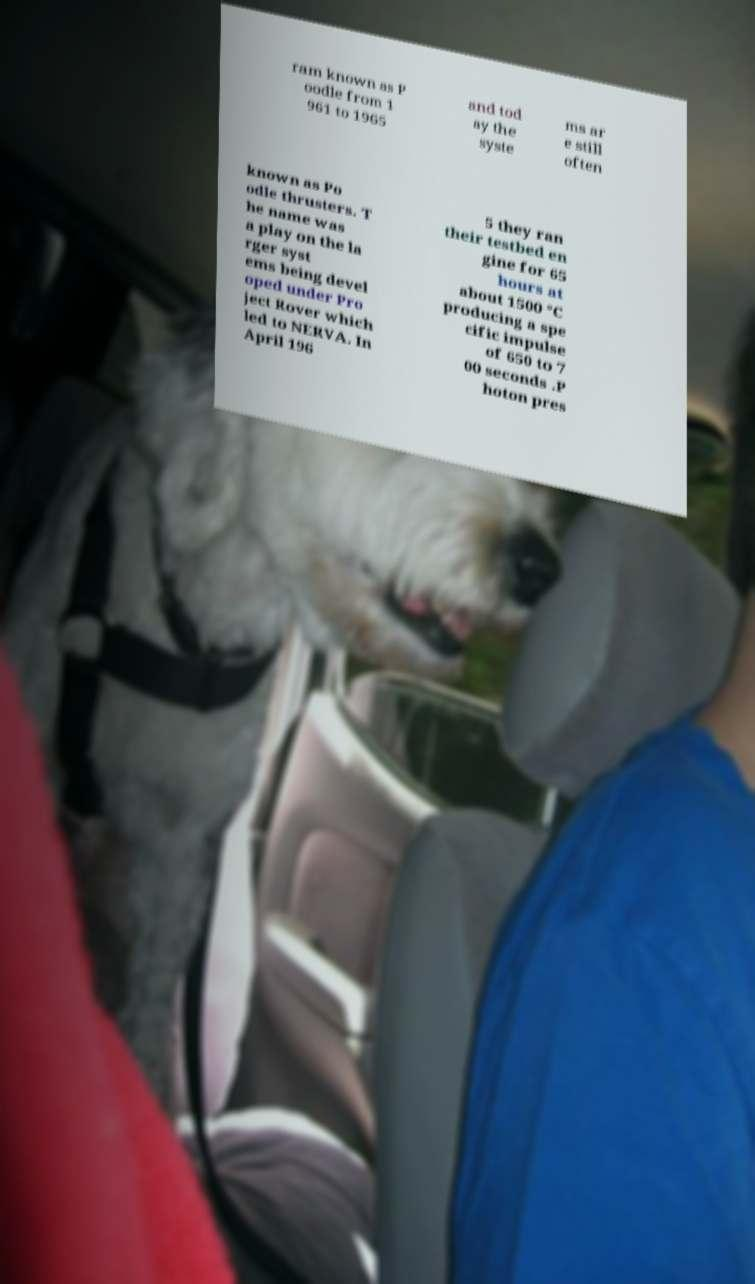Could you assist in decoding the text presented in this image and type it out clearly? ram known as P oodle from 1 961 to 1965 and tod ay the syste ms ar e still often known as Po odle thrusters. T he name was a play on the la rger syst ems being devel oped under Pro ject Rover which led to NERVA. In April 196 5 they ran their testbed en gine for 65 hours at about 1500 °C producing a spe cific impulse of 650 to 7 00 seconds .P hoton pres 